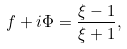Convert formula to latex. <formula><loc_0><loc_0><loc_500><loc_500>f + i \Phi = \frac { \xi - 1 } { \xi + 1 } ,</formula> 